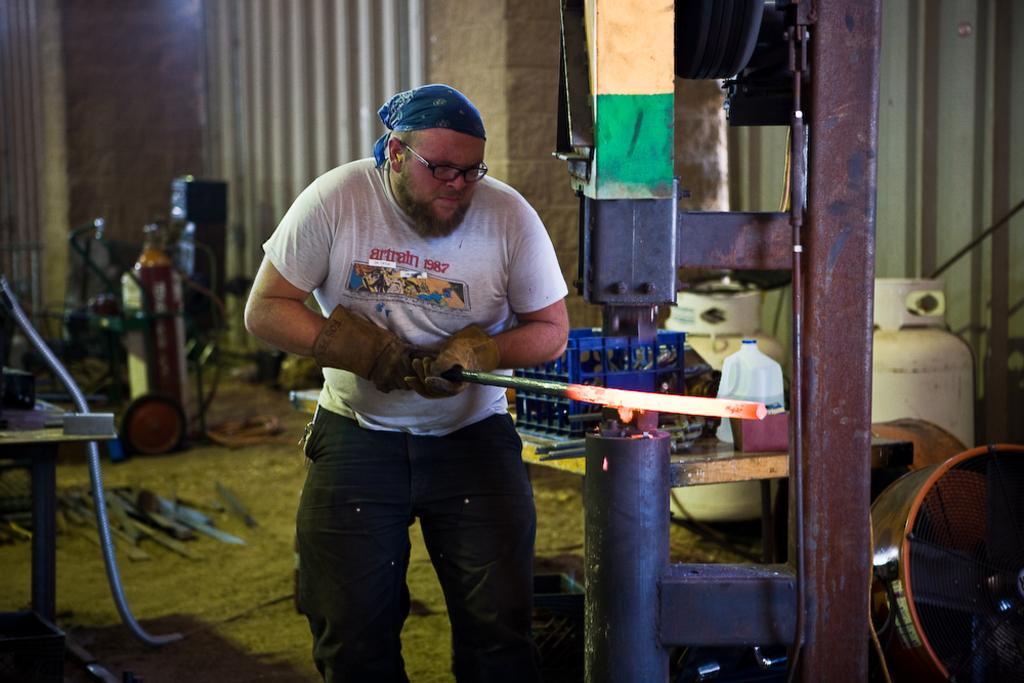How would you summarize this image in a sentence or two? In the center of the image there is a person standing with iron bar. On the left side of the image there are some equipments and tools. On the right side of the image there is a machine, table and some objects. In the background there is a wall. 